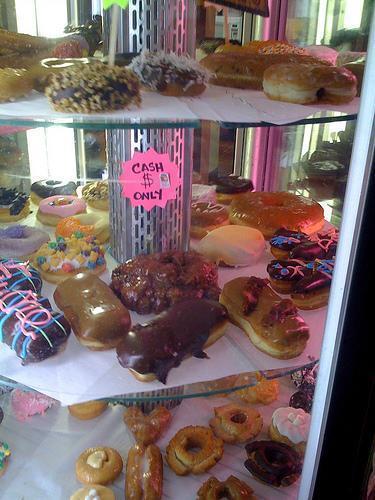How many people are eating cakes?
Give a very brief answer. 0. 